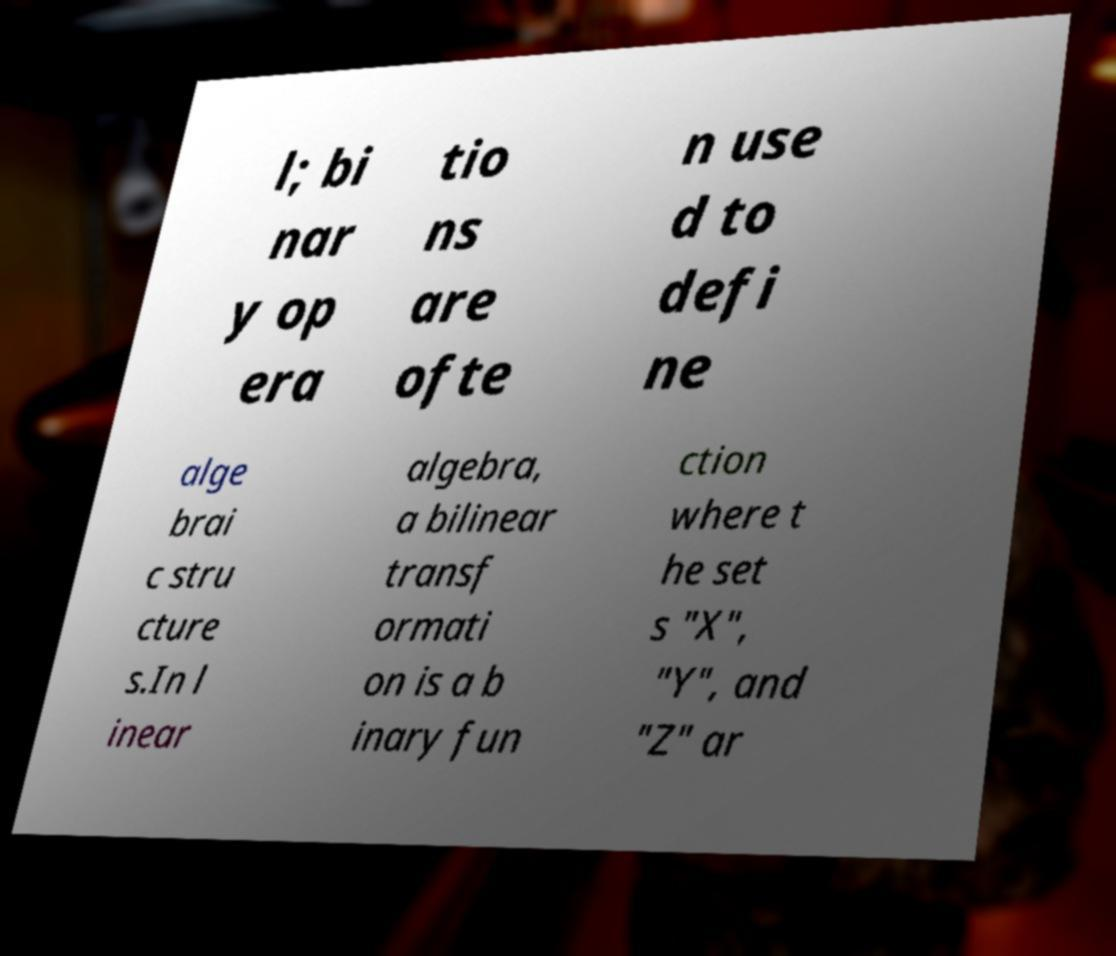Please read and relay the text visible in this image. What does it say? l; bi nar y op era tio ns are ofte n use d to defi ne alge brai c stru cture s.In l inear algebra, a bilinear transf ormati on is a b inary fun ction where t he set s "X", "Y", and "Z" ar 